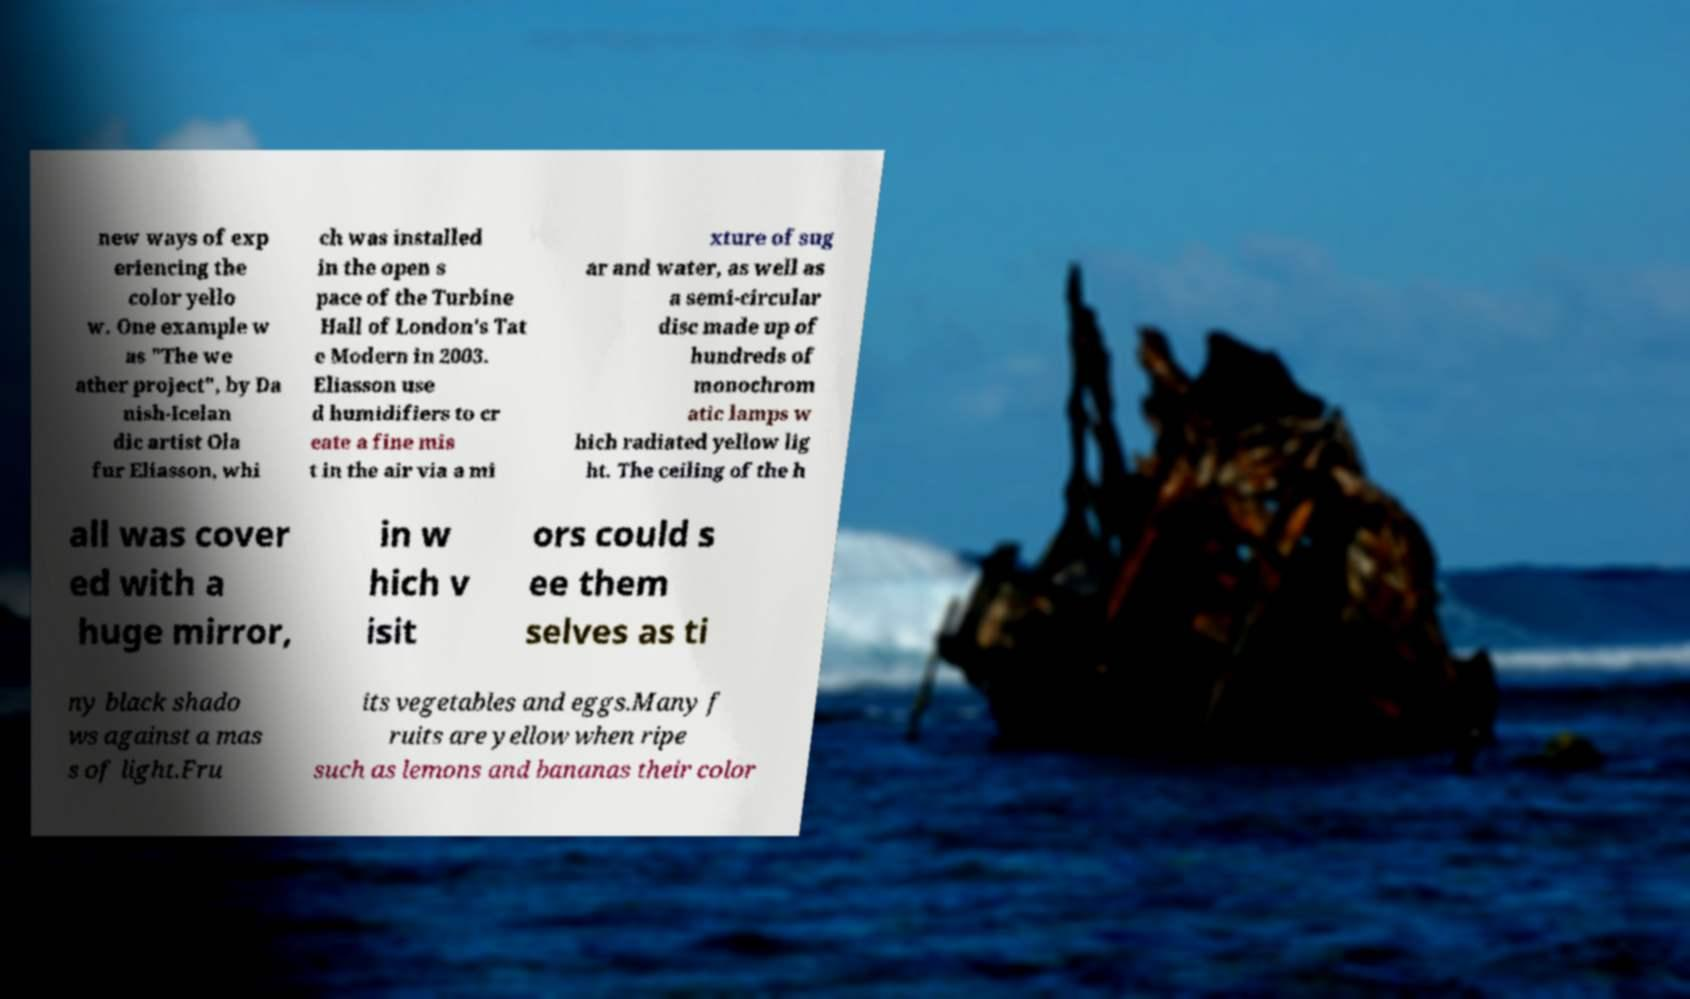There's text embedded in this image that I need extracted. Can you transcribe it verbatim? new ways of exp eriencing the color yello w. One example w as "The we ather project", by Da nish-Icelan dic artist Ola fur Eliasson, whi ch was installed in the open s pace of the Turbine Hall of London's Tat e Modern in 2003. Eliasson use d humidifiers to cr eate a fine mis t in the air via a mi xture of sug ar and water, as well as a semi-circular disc made up of hundreds of monochrom atic lamps w hich radiated yellow lig ht. The ceiling of the h all was cover ed with a huge mirror, in w hich v isit ors could s ee them selves as ti ny black shado ws against a mas s of light.Fru its vegetables and eggs.Many f ruits are yellow when ripe such as lemons and bananas their color 